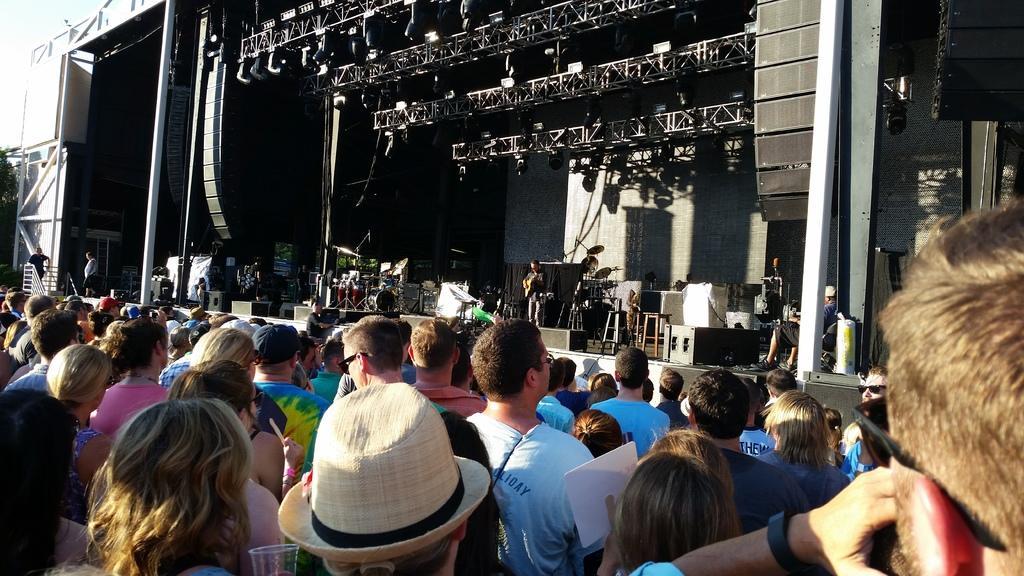How would you summarize this image in a sentence or two? In the foreground I can see a crowd on the road and a group of people are playing musical instruments on the stage. In the background I can see buildings, metal rods, poles, trees and the sky. This image is taken may be on the road. 